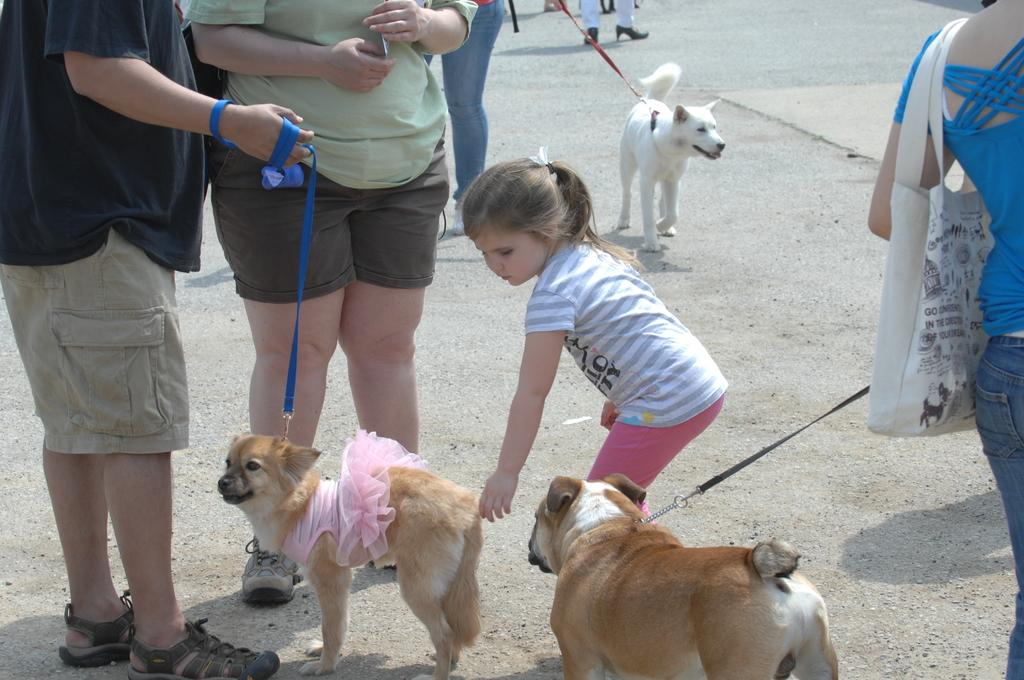What is the main subject of the image? The main subject of the image is a crowd. Are there any animals present in the image? Yes, there are three dogs on the road in the image. When was the image taken? The image was taken during the day. Where was the image taken? The image was taken on the road. How much dirt is visible on the men's shoes in the image? There are no men present in the image, so it is not possible to determine the amount of dirt on their shoes. What is the sun's position in the image? The image was taken during the day, but the sun's position is not visible or mentioned in the provided facts. 